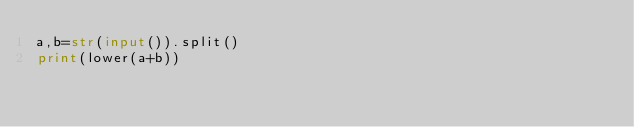Convert code to text. <code><loc_0><loc_0><loc_500><loc_500><_Python_>a,b=str(input()).split()
print(lower(a+b))</code> 